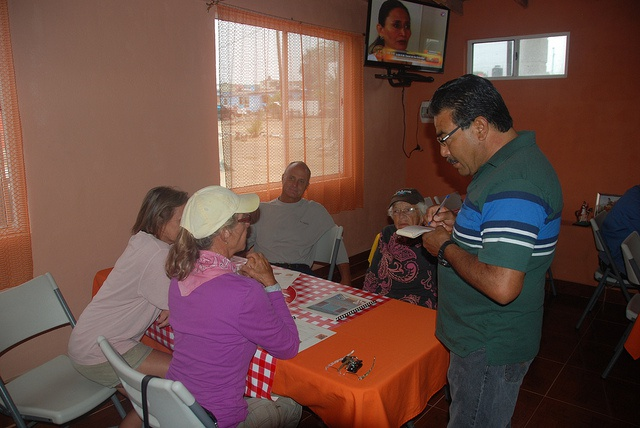Describe the objects in this image and their specific colors. I can see people in maroon, black, purple, and navy tones, dining table in maroon, brown, and darkgray tones, people in maroon, purple, and brown tones, people in maroon and gray tones, and chair in maroon, gray, black, and brown tones in this image. 